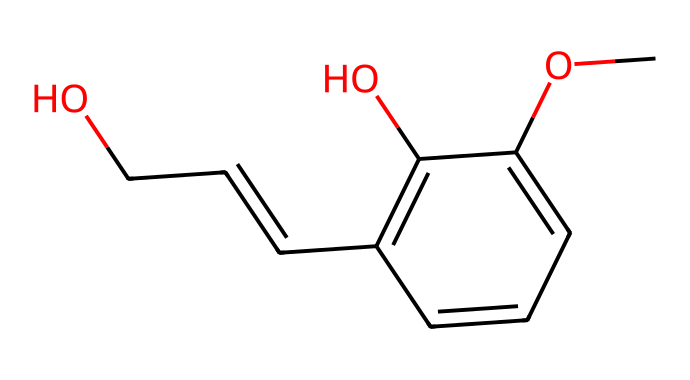What is the main functional group present in this chemical? The SMILES notation indicates the presence of a hydroxyl group (-OH), which is specifically denoted by 'c(O)' in the aromatic ring, indicating its location on the aromatic compound.
Answer: hydroxyl How many carbon atoms are present in the eugenol structure? By analyzing the SMILES, each 'c' represents a carbon atom in the aromatic ring, while the additional 'C' in 'C=CCO' represents carbon atoms outside the ring. Counting them gives a total of 10 carbon atoms in eugenol.
Answer: 10 What type of aromatic compound is eugenol classified as? Eugenol has a phenolic structure, as evidenced by the presence of a hydroxyl group attached to an aromatic ring. Therefore, it is classified as a phenol.
Answer: phenol What role does the methoxy group play in eugenol’s properties? The methoxy group (-OCH3) increases the hydrophobic character of the molecule, enhancing its solubility in nondipolar solvents, which contributes to the overall fragrance properties seen in air fresheners.
Answer: enhances fragrance Is eugenol known for any specific biological activity? Yes, eugenol possesses antibacterial and antifungal properties, which are attributed to the structure's ability to disrupt microbial cell membranes, affecting overall microbial growth and activity.
Answer: antibacterial What characteristic feature allows eugenol to be used in flavoring and fragrance? The aromatic ring structure in eugenol contributes to its volatility and pleasant scent, essential traits for its use in flavoring foods and in air fresheners that aim to improve air quality.
Answer: pleasant scent What is the molecular formula of eugenol based on the given structure? By deriving the molecular formula from the components present in the SMILES notation, eugenol has a formula of C10H12O3, which corresponds to the number of each type of atom identified in the structure.
Answer: C10H12O3 